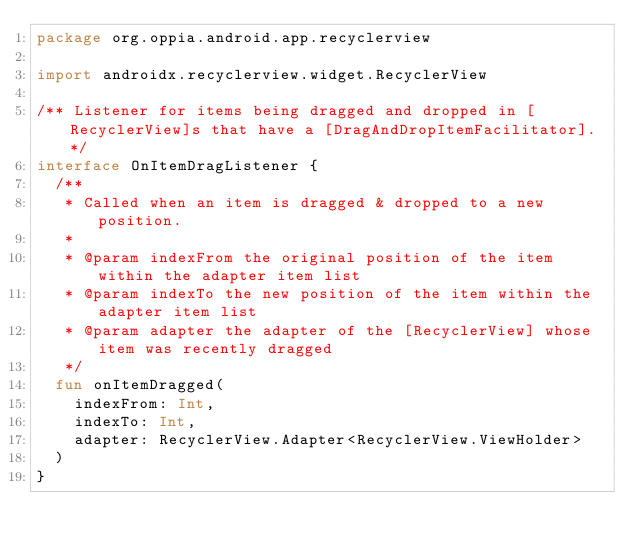<code> <loc_0><loc_0><loc_500><loc_500><_Kotlin_>package org.oppia.android.app.recyclerview

import androidx.recyclerview.widget.RecyclerView

/** Listener for items being dragged and dropped in [RecyclerView]s that have a [DragAndDropItemFacilitator]. */
interface OnItemDragListener {
  /**
   * Called when an item is dragged & dropped to a new position.
   *
   * @param indexFrom the original position of the item within the adapter item list
   * @param indexTo the new position of the item within the adapter item list
   * @param adapter the adapter of the [RecyclerView] whose item was recently dragged
   */
  fun onItemDragged(
    indexFrom: Int,
    indexTo: Int,
    adapter: RecyclerView.Adapter<RecyclerView.ViewHolder>
  )
}
</code> 